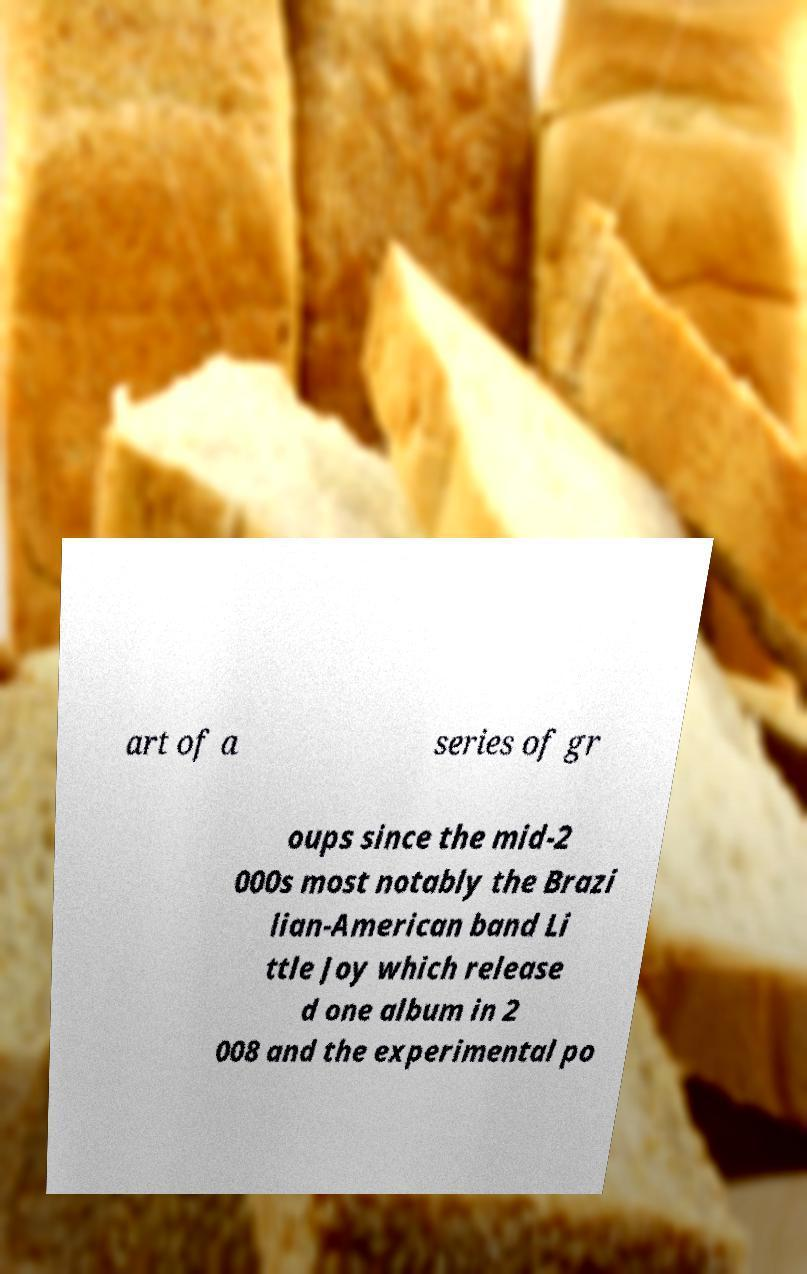There's text embedded in this image that I need extracted. Can you transcribe it verbatim? art of a series of gr oups since the mid-2 000s most notably the Brazi lian-American band Li ttle Joy which release d one album in 2 008 and the experimental po 